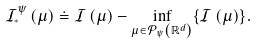<formula> <loc_0><loc_0><loc_500><loc_500>\mathcal { I } _ { ^ { * } } ^ { \psi } \left ( \mu \right ) \doteq \mathcal { I } \left ( \mu \right ) - \inf _ { \mu \in \mathcal { P } _ { \psi } \left ( \mathbb { R } ^ { d } \right ) } \{ \mathcal { I } \left ( \mu \right ) \} .</formula> 